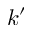Convert formula to latex. <formula><loc_0><loc_0><loc_500><loc_500>k ^ { \prime }</formula> 